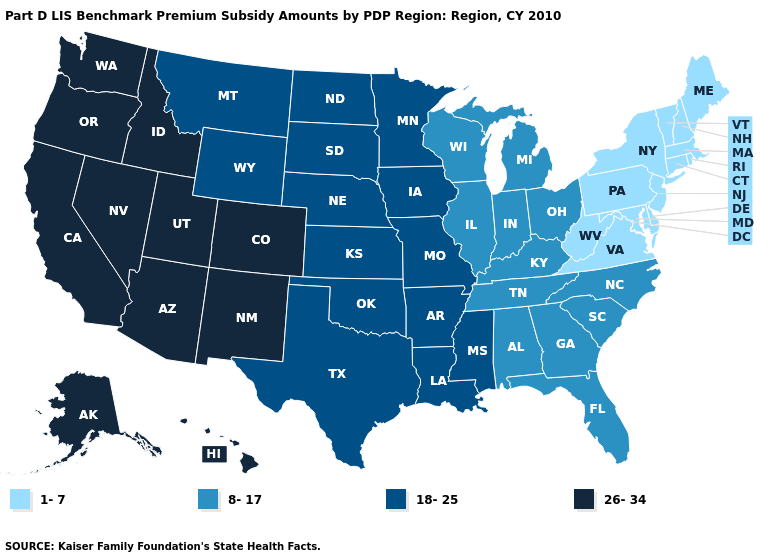Does Washington have the highest value in the USA?
Give a very brief answer. Yes. Name the states that have a value in the range 1-7?
Answer briefly. Connecticut, Delaware, Maine, Maryland, Massachusetts, New Hampshire, New Jersey, New York, Pennsylvania, Rhode Island, Vermont, Virginia, West Virginia. Does the map have missing data?
Short answer required. No. Is the legend a continuous bar?
Concise answer only. No. Which states have the lowest value in the West?
Be succinct. Montana, Wyoming. Which states have the lowest value in the MidWest?
Give a very brief answer. Illinois, Indiana, Michigan, Ohio, Wisconsin. Does Nebraska have the highest value in the MidWest?
Be succinct. Yes. What is the lowest value in the West?
Be succinct. 18-25. Does the map have missing data?
Answer briefly. No. What is the value of Florida?
Short answer required. 8-17. What is the value of New Jersey?
Short answer required. 1-7. Does Georgia have a lower value than Kansas?
Short answer required. Yes. Name the states that have a value in the range 26-34?
Short answer required. Alaska, Arizona, California, Colorado, Hawaii, Idaho, Nevada, New Mexico, Oregon, Utah, Washington. What is the lowest value in the USA?
Short answer required. 1-7. Among the states that border Virginia , does North Carolina have the lowest value?
Give a very brief answer. No. 